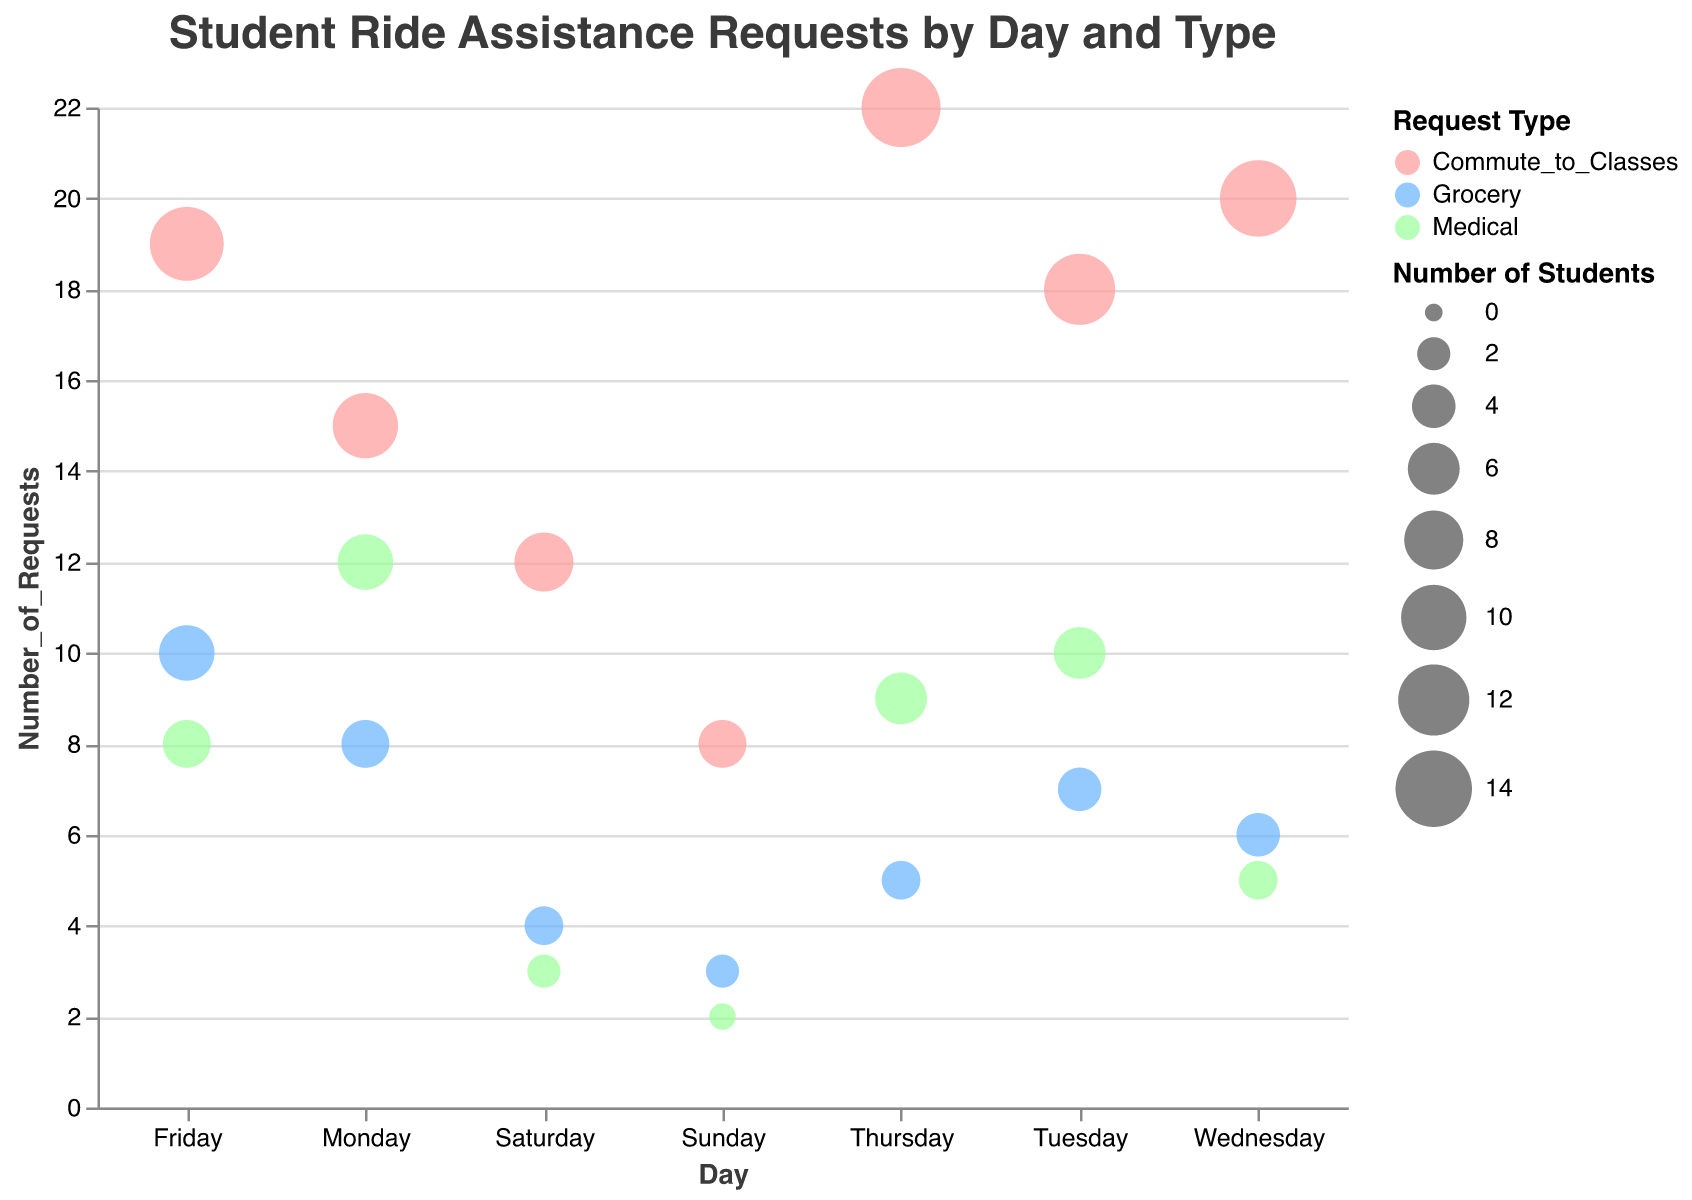How many times did students request rides for Medical reasons on Wednesday? First, identify the data points for Wednesday in the Medical category. The chart indicates 5 requests for Medical reasons on this day.
Answer: 5 What day has the highest number of requests for Commute to Classes? Look for the largest bubble in the Commute to Classes color category. Thursday has the largest bubble representing 22 requests.
Answer: Thursday Compare the number of Grocery requests on Friday and Sunday. Which day has more requests and by how much? On Friday, there are 10 Grocery requests, and on Sunday, there are 3. The difference is 10 - 3 = 7; therefore, Friday has 7 more requests than Sunday.
Answer: Friday, 7 more What is the total number of Medical requests across all days? Sum the number of requests in the Medical category from each day: 12 (Mon) + 10 (Tue) + 5 (Wed) + 9 (Thu) + 8 (Fri) + 3 (Sat) + 2 (Sun) = 49.
Answer: 49 Which day has the least number of total requests, and what is that number? Count the total requests per day by adding up all the request types. Sunday has the least number with 2 (Medical) + 3 (Grocery) + 8 (Commute to Classes) = 13 requests.
Answer: Sunday, 13 For Grocery requests, which day has the largest bubble size indicating the most students affected? Compare the bubbles for Grocery requests. The largest bubble for Grocery requests is on Friday, with 7 students.
Answer: Friday On which day do students request rides for Commute to Classes the least, and what is the number of requests? Look for the day with the smallest bubble in the Commute to Classes category. Sunday has the fewest requests with 8.
Answer: Sunday, 8 If we combined the total requests for Monday and Tuesday, how many would there be for Commute to Classes? Add the number of Commute to Classes requests for Monday and Tuesday: 15 (Mon) + 18 (Tue) = 33.
Answer: 33 